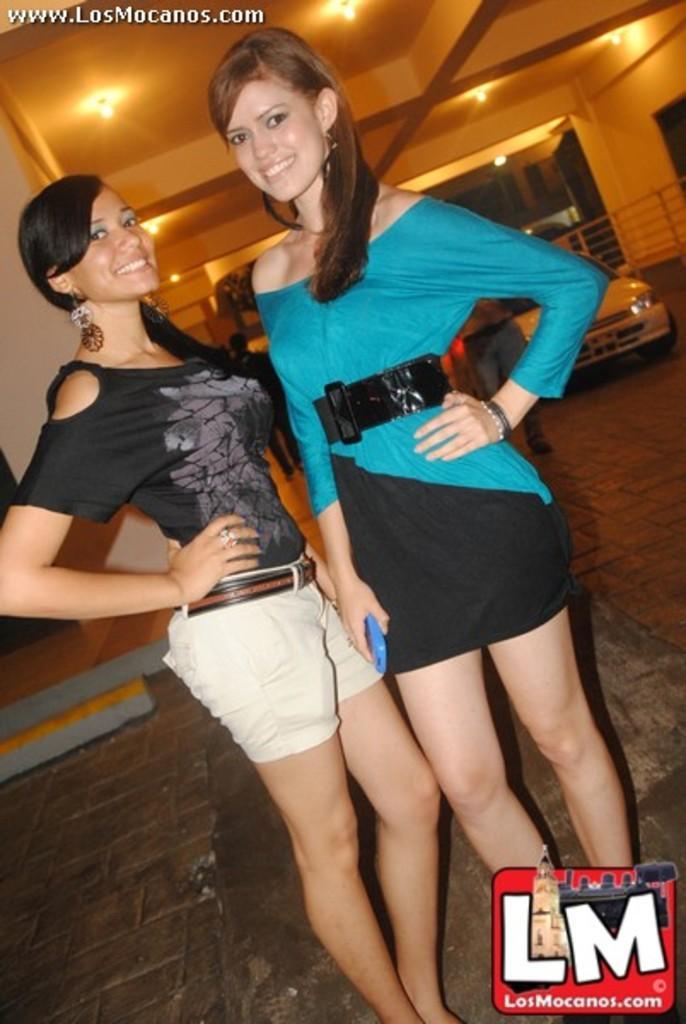How would you summarize this image in a sentence or two? In this image I can see two persons standing, the person at right is wearing blue and black color dress and the person at left is wearing black and cream color dress. Background I can see few vehicles and I can also see few lights. 